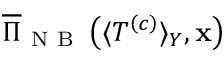Convert formula to latex. <formula><loc_0><loc_0><loc_500><loc_500>\overline { \Pi } _ { N B } \left ( \langle T ^ { \left ( c \right ) } \rangle _ { Y } , x \right )</formula> 